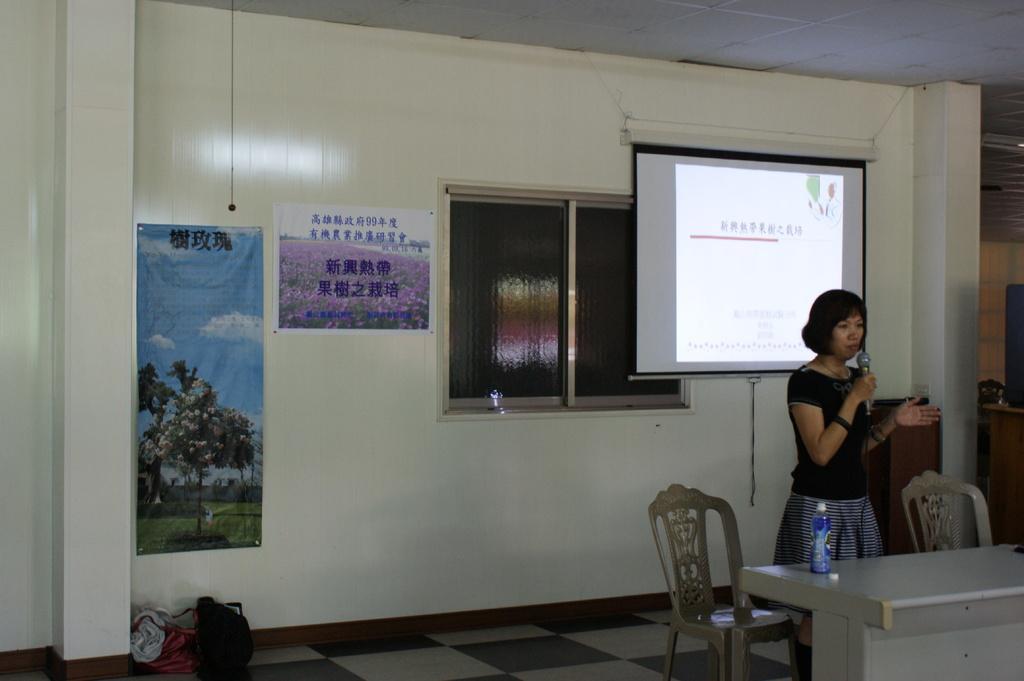Please provide a concise description of this image. In this picture we can see a woman holding a mic with her hand and standing, chairs, bottle on a table, screen, window, posters on the wall. 